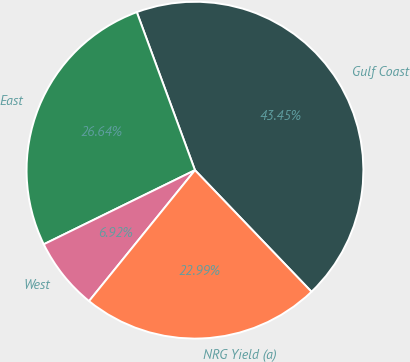<chart> <loc_0><loc_0><loc_500><loc_500><pie_chart><fcel>Gulf Coast<fcel>East<fcel>West<fcel>NRG Yield (a)<nl><fcel>43.45%<fcel>26.64%<fcel>6.92%<fcel>22.99%<nl></chart> 